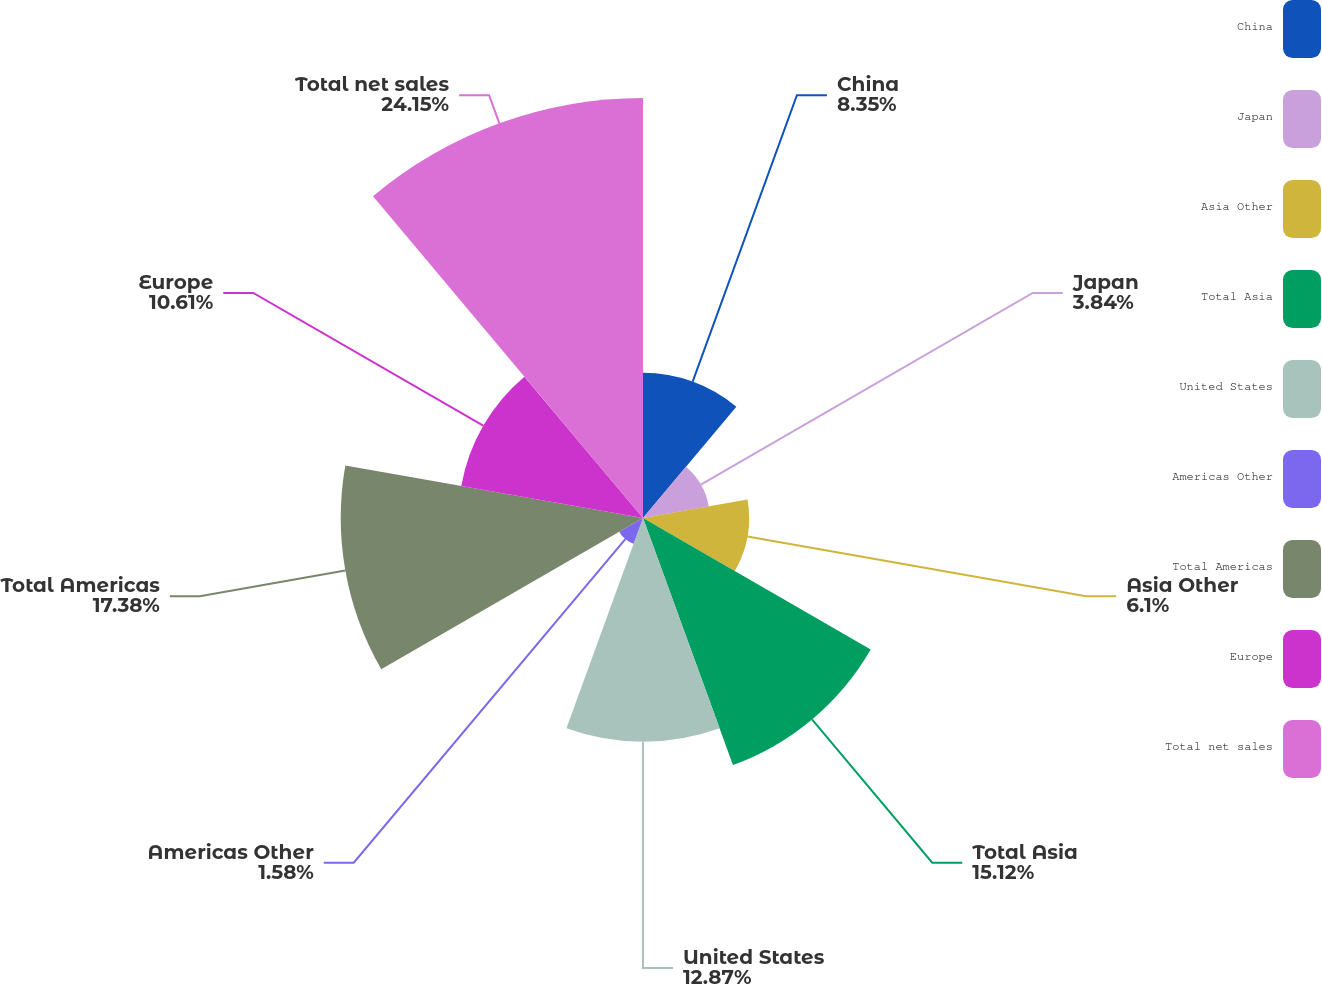<chart> <loc_0><loc_0><loc_500><loc_500><pie_chart><fcel>China<fcel>Japan<fcel>Asia Other<fcel>Total Asia<fcel>United States<fcel>Americas Other<fcel>Total Americas<fcel>Europe<fcel>Total net sales<nl><fcel>8.35%<fcel>3.84%<fcel>6.1%<fcel>15.12%<fcel>12.87%<fcel>1.58%<fcel>17.38%<fcel>10.61%<fcel>24.15%<nl></chart> 